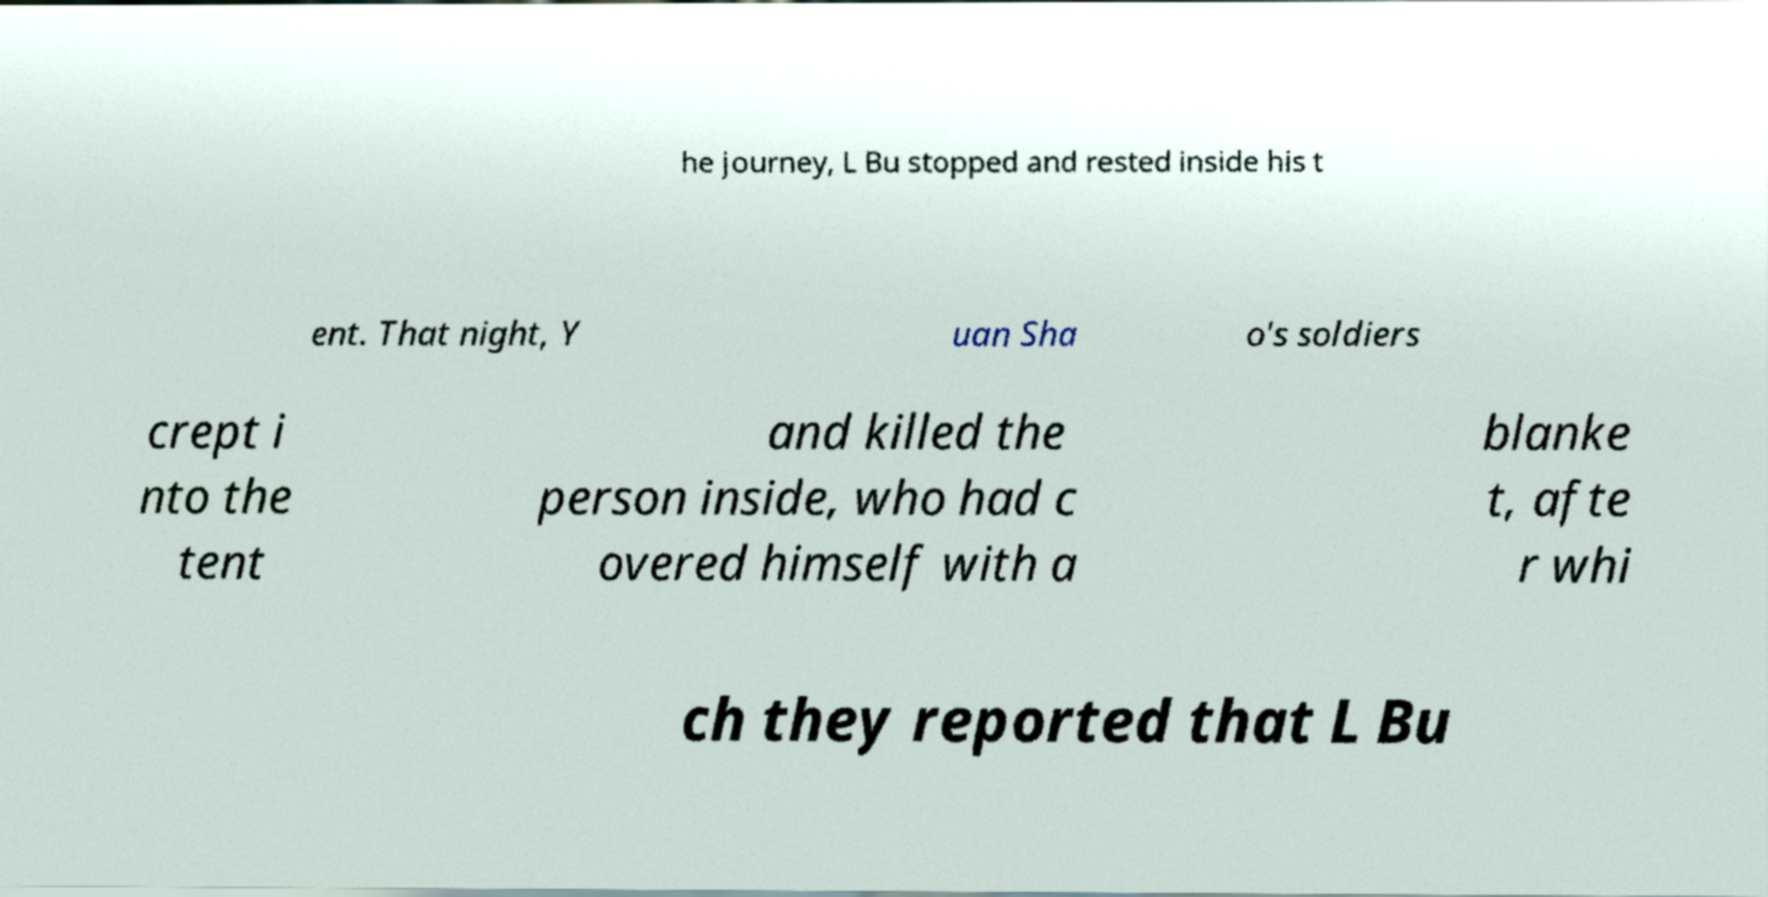What messages or text are displayed in this image? I need them in a readable, typed format. he journey, L Bu stopped and rested inside his t ent. That night, Y uan Sha o's soldiers crept i nto the tent and killed the person inside, who had c overed himself with a blanke t, afte r whi ch they reported that L Bu 